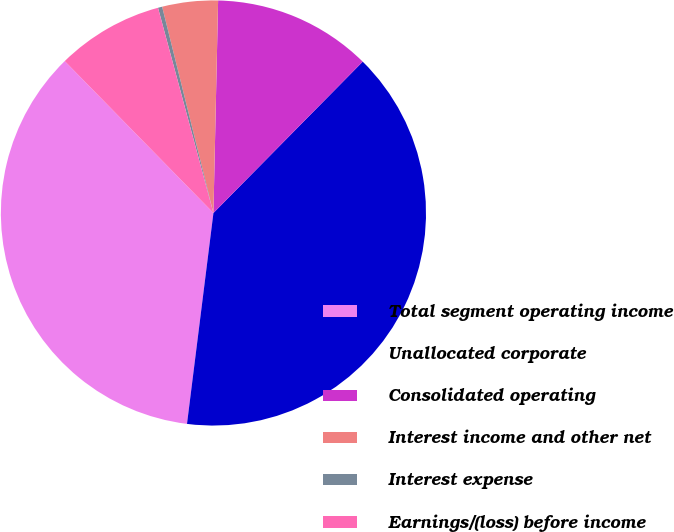Convert chart. <chart><loc_0><loc_0><loc_500><loc_500><pie_chart><fcel>Total segment operating income<fcel>Unallocated corporate<fcel>Consolidated operating<fcel>Interest income and other net<fcel>Interest expense<fcel>Earnings/(loss) before income<nl><fcel>35.68%<fcel>39.59%<fcel>12.04%<fcel>4.23%<fcel>0.32%<fcel>8.13%<nl></chart> 